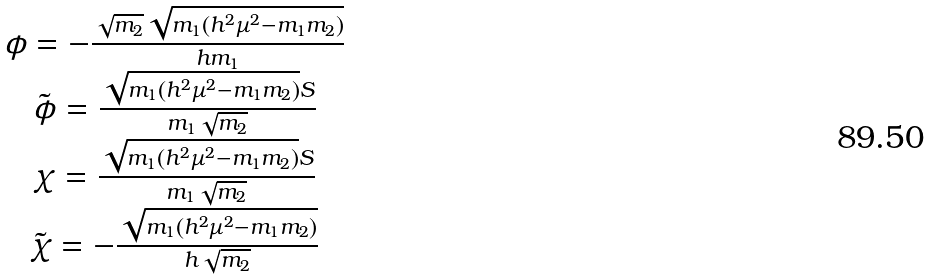<formula> <loc_0><loc_0><loc_500><loc_500>\begin{array} { c } \phi = - \frac { \sqrt { m _ { 2 } } \sqrt { m _ { 1 } ( h ^ { 2 } \mu ^ { 2 } - m _ { 1 } m _ { 2 } ) } } { h m _ { 1 } } \\ \tilde { \phi } = \frac { \sqrt { m _ { 1 } ( h ^ { 2 } \mu ^ { 2 } - m _ { 1 } m _ { 2 } ) } S } { m _ { 1 } \sqrt { m _ { 2 } } } \\ \chi = \frac { \sqrt { m _ { 1 } ( h ^ { 2 } \mu ^ { 2 } - m _ { 1 } m _ { 2 } ) } S } { m _ { 1 } \sqrt { m _ { 2 } } } \\ \tilde { \chi } = - \frac { \sqrt { m _ { 1 } ( h ^ { 2 } \mu ^ { 2 } - m _ { 1 } m _ { 2 } ) } } { h \sqrt { m _ { 2 } } } \\ \end{array}</formula> 